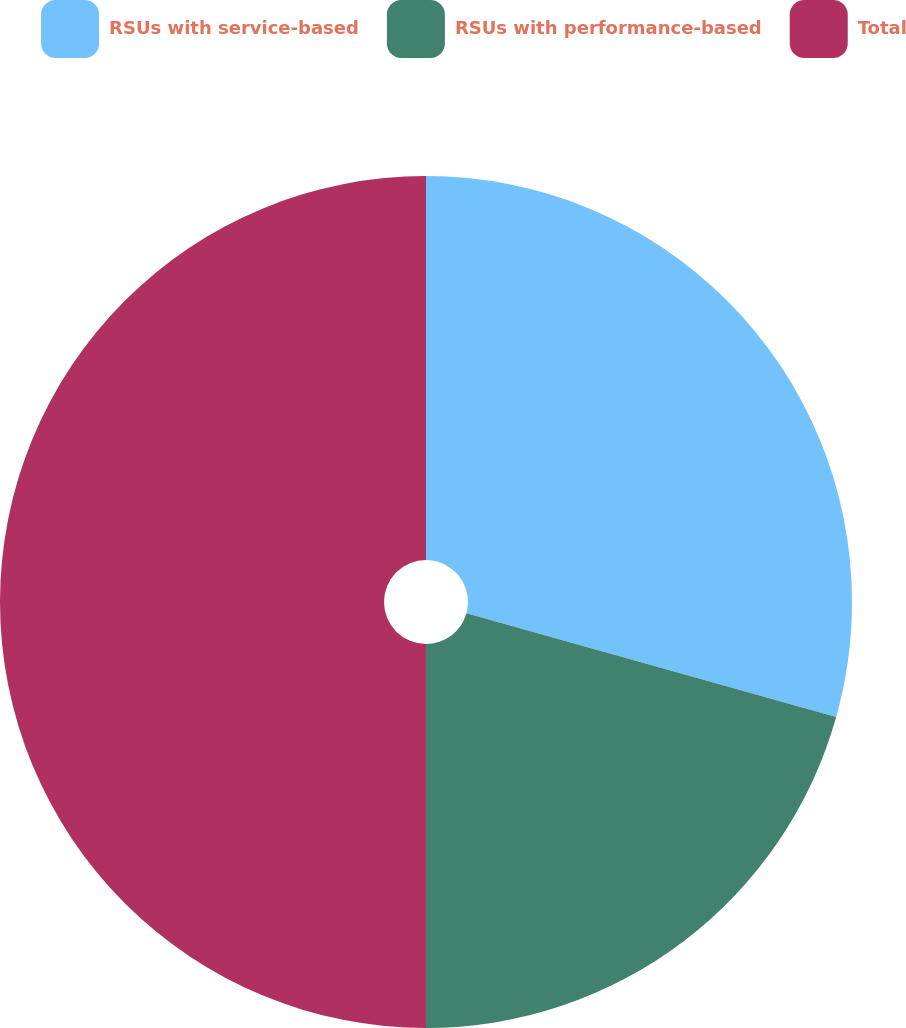<chart> <loc_0><loc_0><loc_500><loc_500><pie_chart><fcel>RSUs with service-based<fcel>RSUs with performance-based<fcel>Total<nl><fcel>29.35%<fcel>20.65%<fcel>50.0%<nl></chart> 